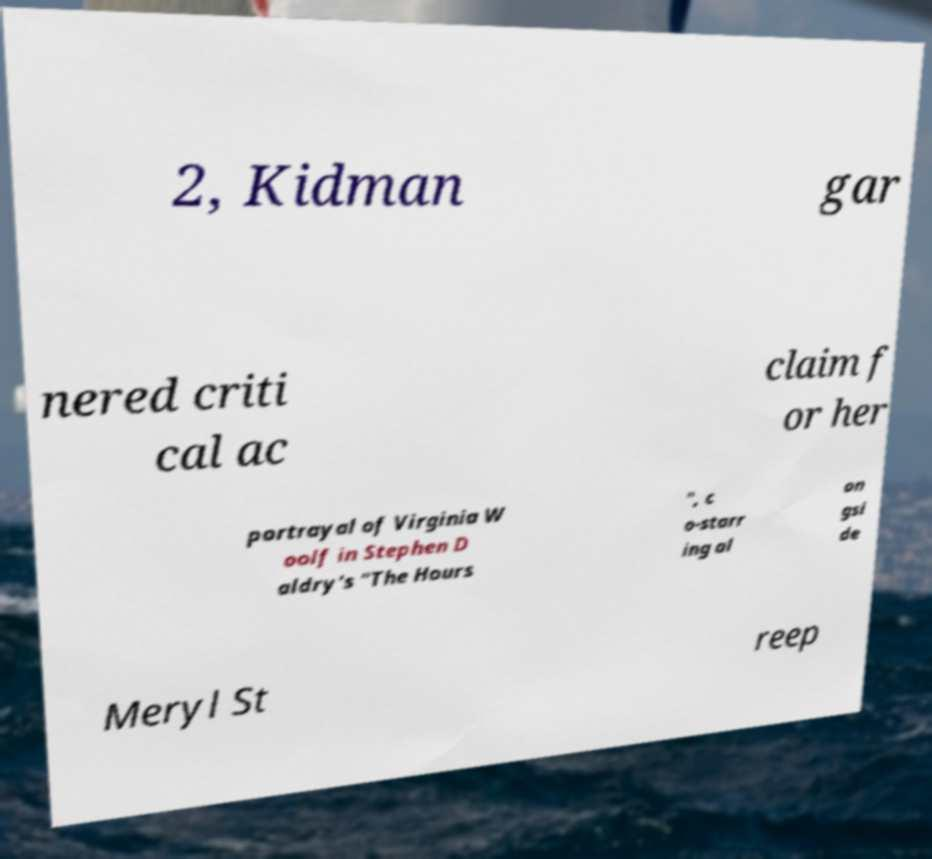I need the written content from this picture converted into text. Can you do that? 2, Kidman gar nered criti cal ac claim f or her portrayal of Virginia W oolf in Stephen D aldry's "The Hours ", c o-starr ing al on gsi de Meryl St reep 